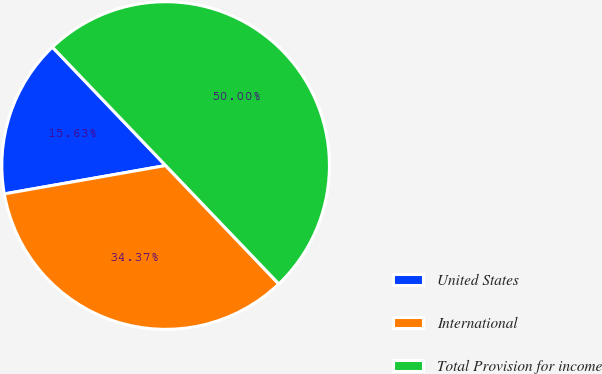Convert chart to OTSL. <chart><loc_0><loc_0><loc_500><loc_500><pie_chart><fcel>United States<fcel>International<fcel>Total Provision for income<nl><fcel>15.63%<fcel>34.37%<fcel>50.0%<nl></chart> 